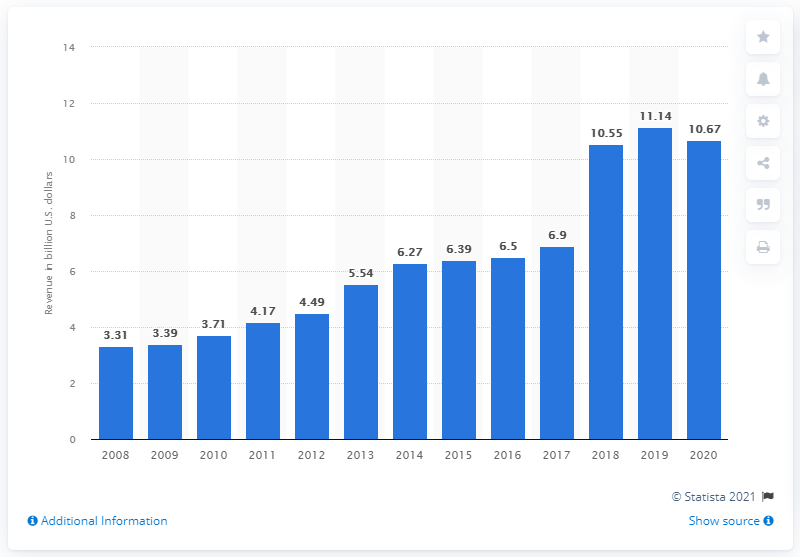Highlight a few significant elements in this photo. In 2020, Discovery Communications' revenue was 10.67... In the previous year, Discovery Communications' revenue was 11.14. 